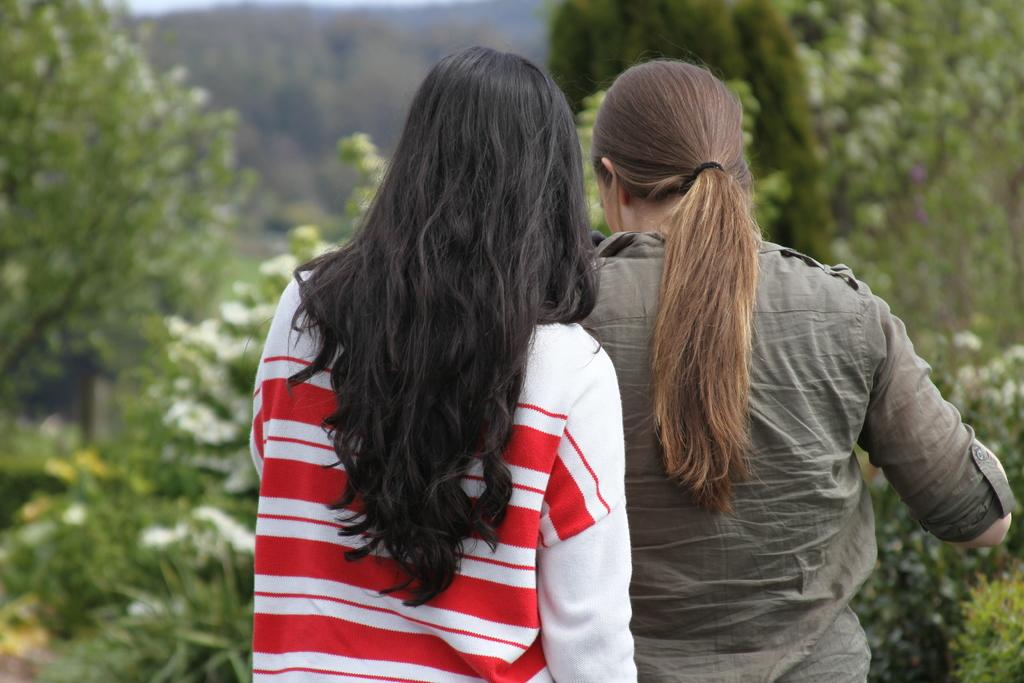How many people are in the image? There are two women standing in the middle of the image. What can be seen in the background of the image? There are trees in the background of the image. How is the background of the image depicted? The background is blurred. What type of foot is visible on the left side of the image? There is no foot visible on the left side of the image. How does the journey of the women in the image progress? The image does not depict a journey, so it cannot be determined how the women's journey progresses. 